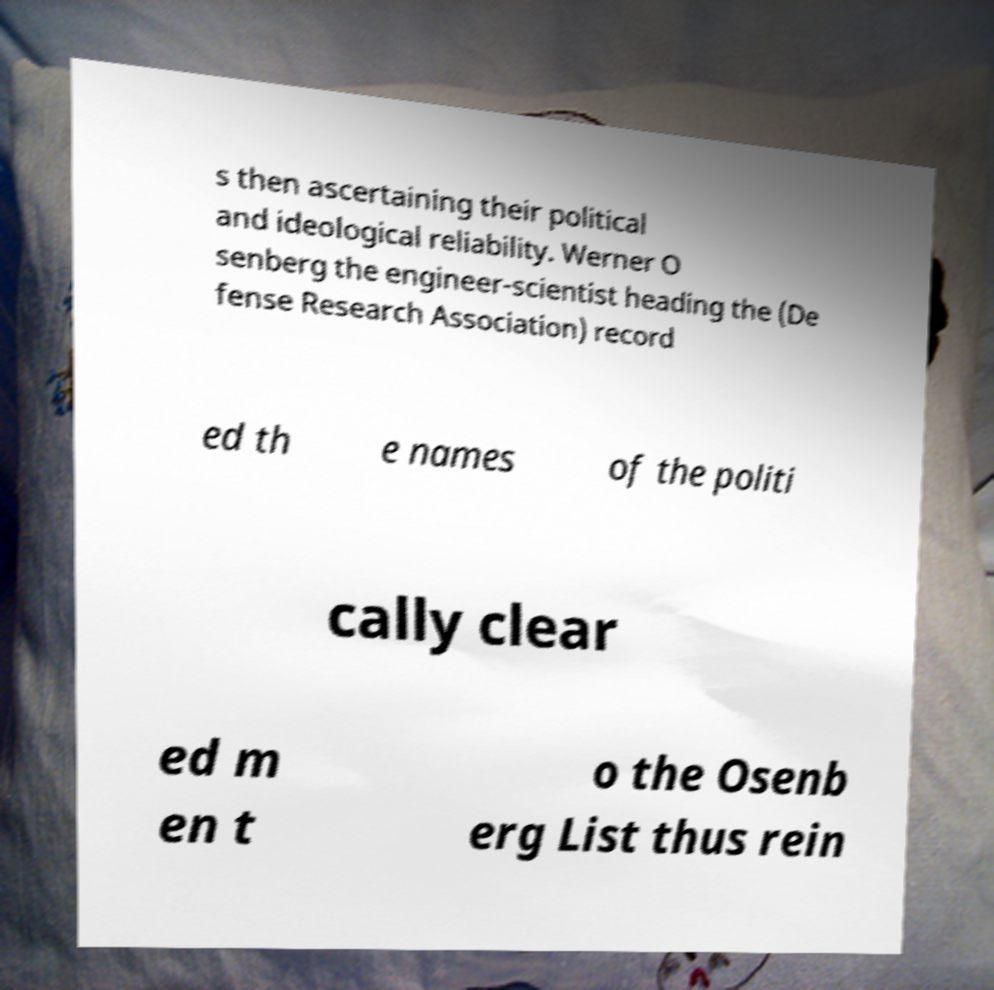Please identify and transcribe the text found in this image. s then ascertaining their political and ideological reliability. Werner O senberg the engineer-scientist heading the (De fense Research Association) record ed th e names of the politi cally clear ed m en t o the Osenb erg List thus rein 